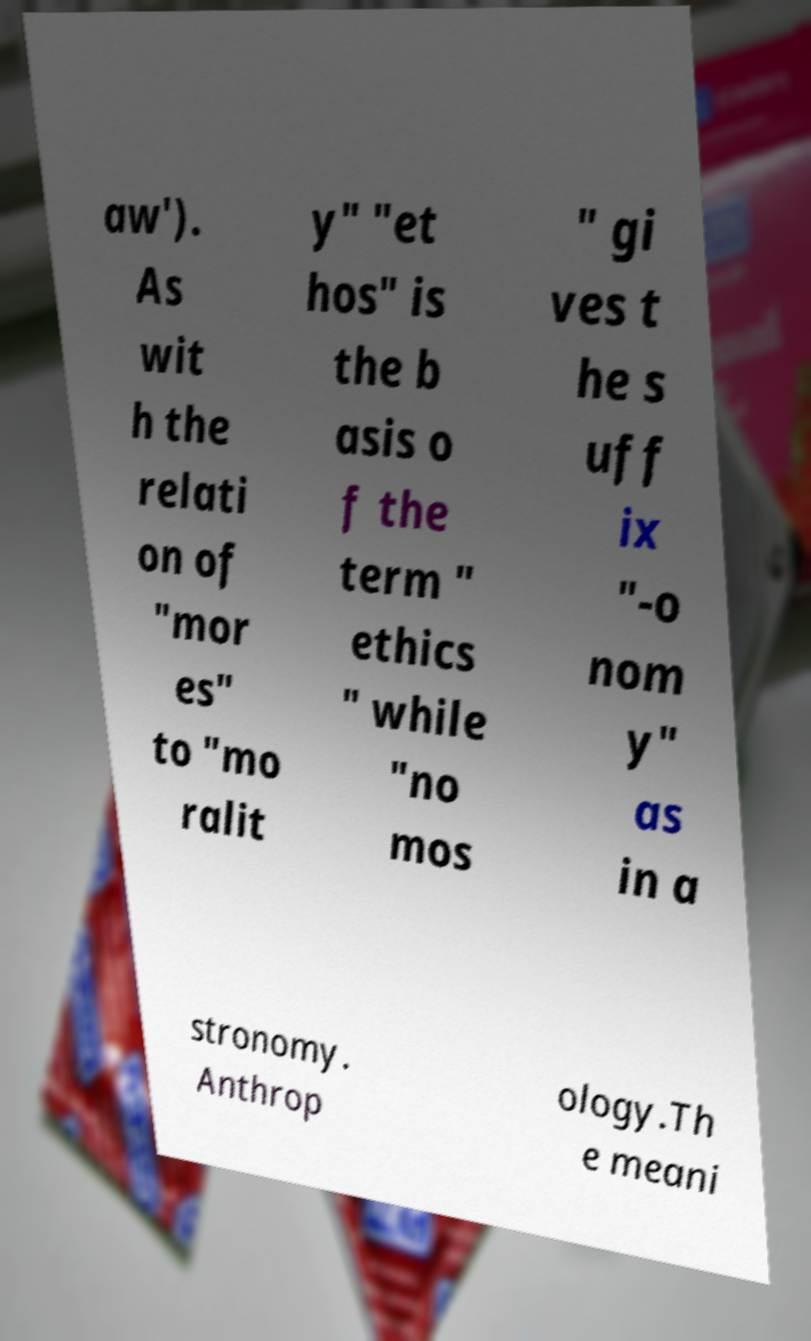Could you extract and type out the text from this image? aw'). As wit h the relati on of "mor es" to "mo ralit y" "et hos" is the b asis o f the term " ethics " while "no mos " gi ves t he s uff ix "-o nom y" as in a stronomy. Anthrop ology.Th e meani 